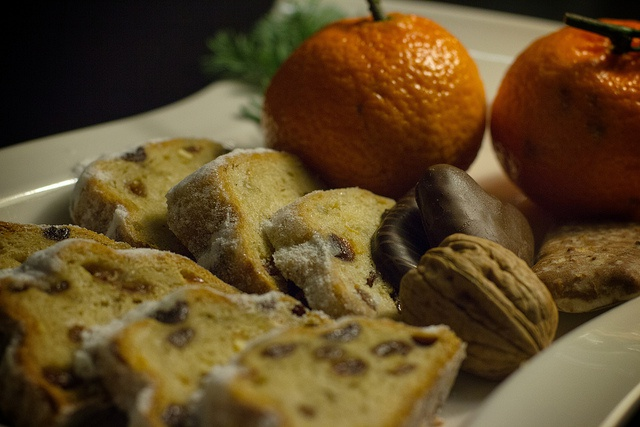Describe the objects in this image and their specific colors. I can see bowl in black, maroon, and olive tones, orange in black, maroon, brown, and orange tones, orange in black, maroon, and brown tones, cake in black and olive tones, and cake in black, olive, and maroon tones in this image. 